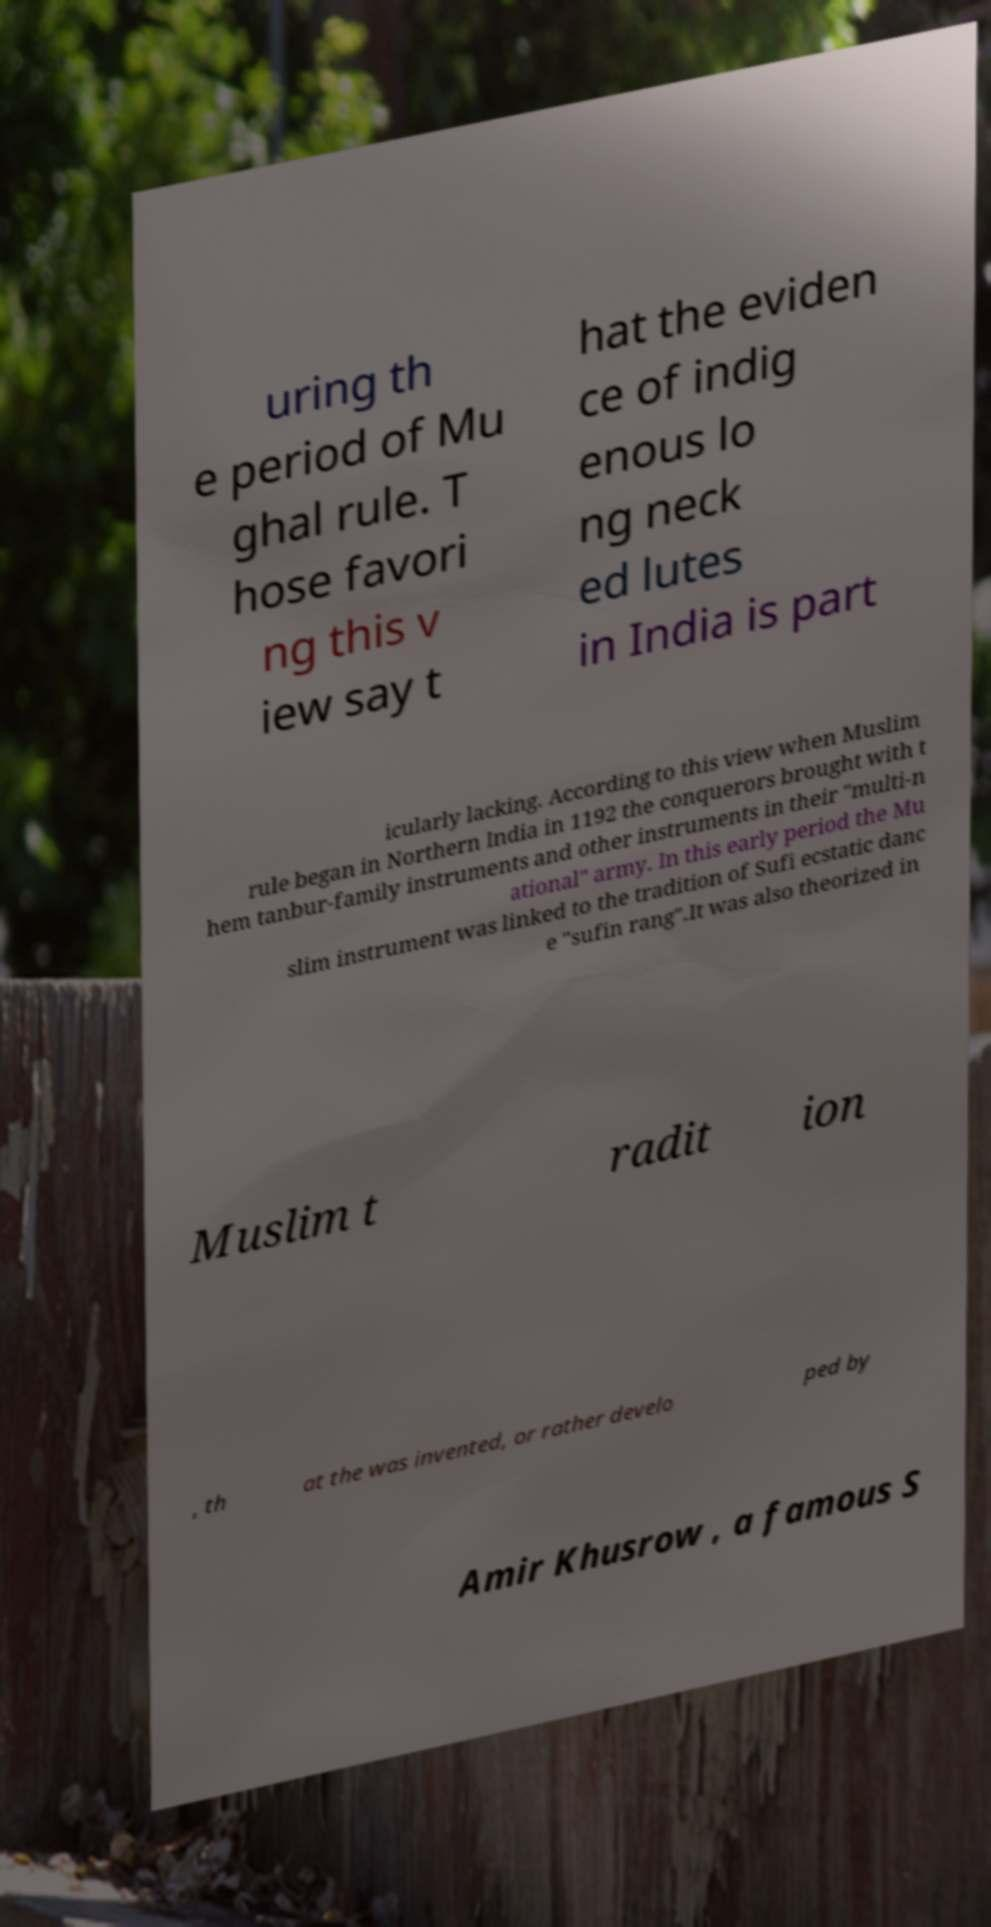I need the written content from this picture converted into text. Can you do that? uring th e period of Mu ghal rule. T hose favori ng this v iew say t hat the eviden ce of indig enous lo ng neck ed lutes in India is part icularly lacking. According to this view when Muslim rule began in Northern India in 1192 the conquerors brought with t hem tanbur-family instruments and other instruments in their "multi-n ational" army. In this early period the Mu slim instrument was linked to the tradition of Sufi ecstatic danc e "sufin rang".It was also theorized in Muslim t radit ion , th at the was invented, or rather develo ped by Amir Khusrow , a famous S 